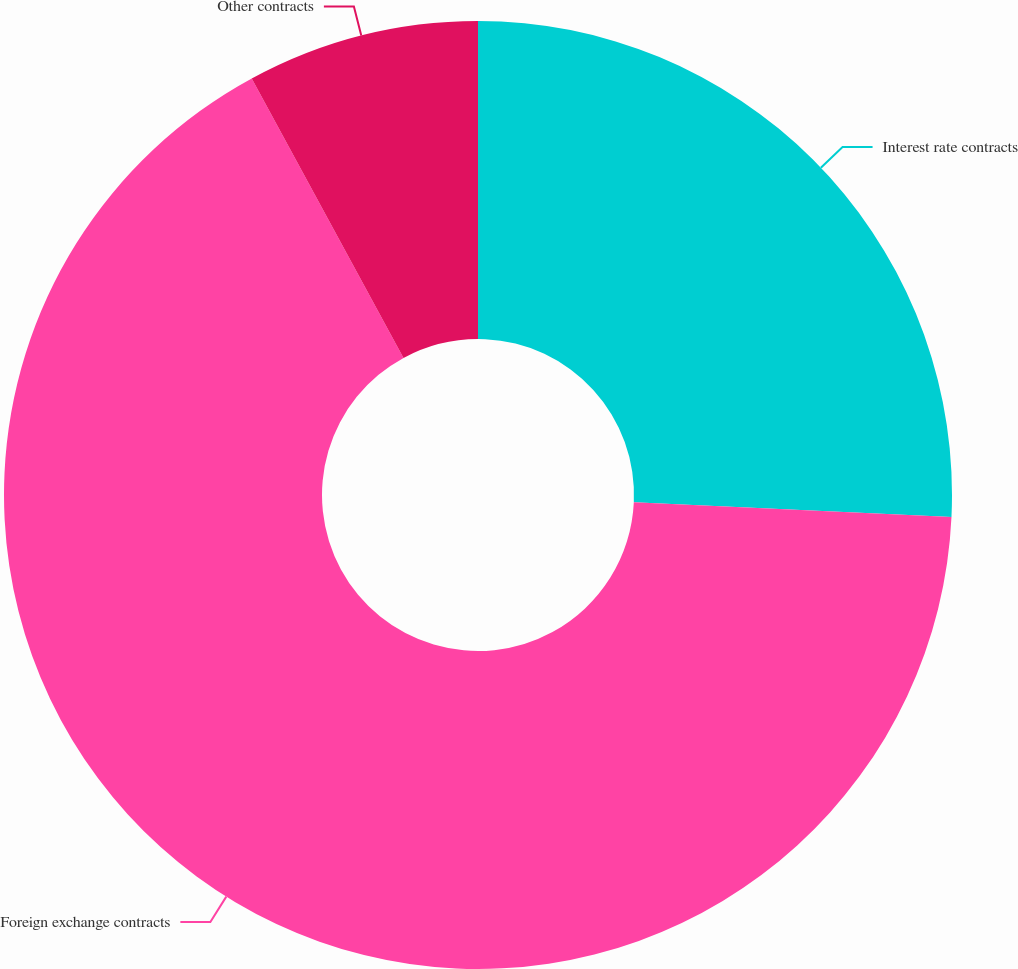<chart> <loc_0><loc_0><loc_500><loc_500><pie_chart><fcel>Interest rate contracts<fcel>Foreign exchange contracts<fcel>Other contracts<nl><fcel>25.74%<fcel>66.34%<fcel>7.92%<nl></chart> 